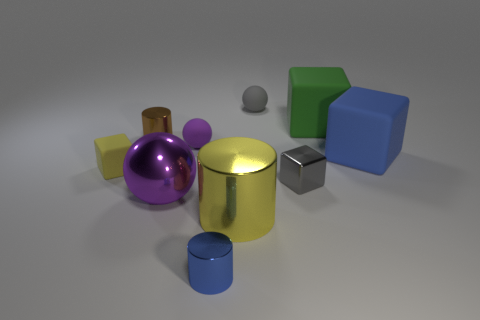There is a blue object behind the small cube on the left side of the big metallic cylinder; what is its size?
Offer a very short reply. Large. There is a cylinder that is on the right side of the blue cylinder; is its size the same as the large shiny sphere?
Offer a terse response. Yes. Are there more green things that are in front of the blue metal cylinder than tiny gray cubes that are in front of the brown cylinder?
Offer a terse response. No. There is a large thing that is both behind the large purple metal object and in front of the big green rubber thing; what shape is it?
Ensure brevity in your answer.  Cube. There is a small object to the left of the brown metallic cylinder; what is its shape?
Give a very brief answer. Cube. How big is the matte sphere that is in front of the small rubber ball that is right of the blue object that is in front of the small yellow matte object?
Offer a terse response. Small. Is the shape of the tiny gray rubber thing the same as the yellow metallic object?
Provide a short and direct response. No. What size is the ball that is behind the blue cube and on the left side of the big yellow cylinder?
Provide a short and direct response. Small. What is the material of the gray object that is the same shape as the big green thing?
Give a very brief answer. Metal. What material is the blue object to the left of the cube that is in front of the small yellow rubber block made of?
Your answer should be very brief. Metal. 